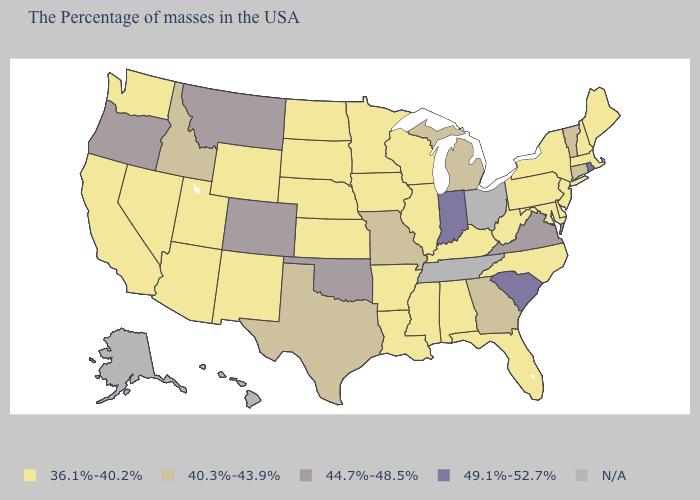Name the states that have a value in the range N/A?
Quick response, please. Ohio, Tennessee, Alaska, Hawaii. Name the states that have a value in the range 36.1%-40.2%?
Answer briefly. Maine, Massachusetts, New Hampshire, New York, New Jersey, Delaware, Maryland, Pennsylvania, North Carolina, West Virginia, Florida, Kentucky, Alabama, Wisconsin, Illinois, Mississippi, Louisiana, Arkansas, Minnesota, Iowa, Kansas, Nebraska, South Dakota, North Dakota, Wyoming, New Mexico, Utah, Arizona, Nevada, California, Washington. What is the value of Virginia?
Give a very brief answer. 44.7%-48.5%. How many symbols are there in the legend?
Answer briefly. 5. What is the value of Georgia?
Give a very brief answer. 40.3%-43.9%. Does Missouri have the lowest value in the USA?
Write a very short answer. No. What is the value of Mississippi?
Keep it brief. 36.1%-40.2%. What is the value of Arizona?
Short answer required. 36.1%-40.2%. Which states have the lowest value in the Northeast?
Quick response, please. Maine, Massachusetts, New Hampshire, New York, New Jersey, Pennsylvania. What is the value of New Mexico?
Give a very brief answer. 36.1%-40.2%. Which states have the highest value in the USA?
Concise answer only. Rhode Island, South Carolina, Indiana. Among the states that border Montana , which have the highest value?
Answer briefly. Idaho. Name the states that have a value in the range 49.1%-52.7%?
Short answer required. Rhode Island, South Carolina, Indiana. Does Rhode Island have the highest value in the Northeast?
Concise answer only. Yes. What is the highest value in the USA?
Short answer required. 49.1%-52.7%. 